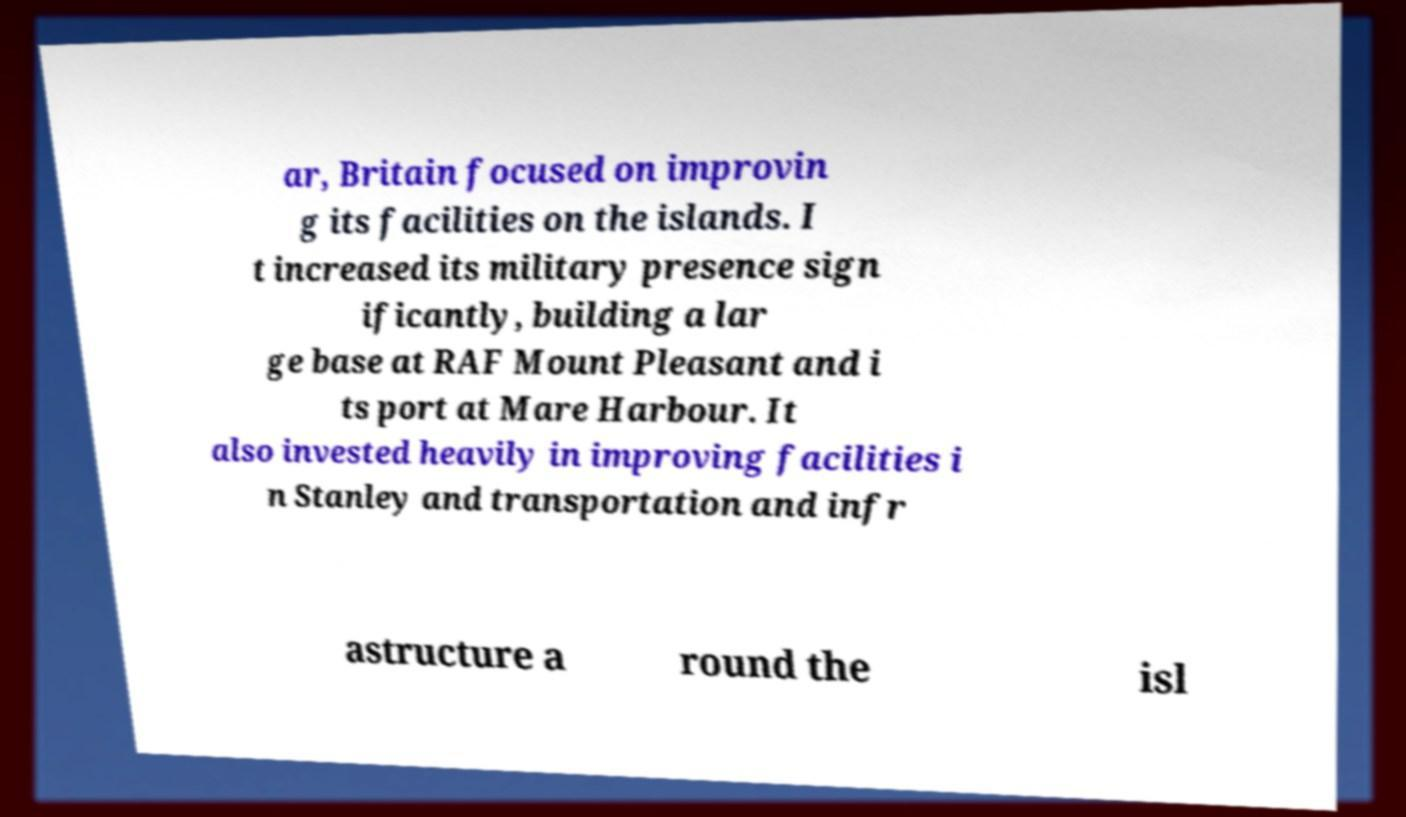Please identify and transcribe the text found in this image. ar, Britain focused on improvin g its facilities on the islands. I t increased its military presence sign ificantly, building a lar ge base at RAF Mount Pleasant and i ts port at Mare Harbour. It also invested heavily in improving facilities i n Stanley and transportation and infr astructure a round the isl 